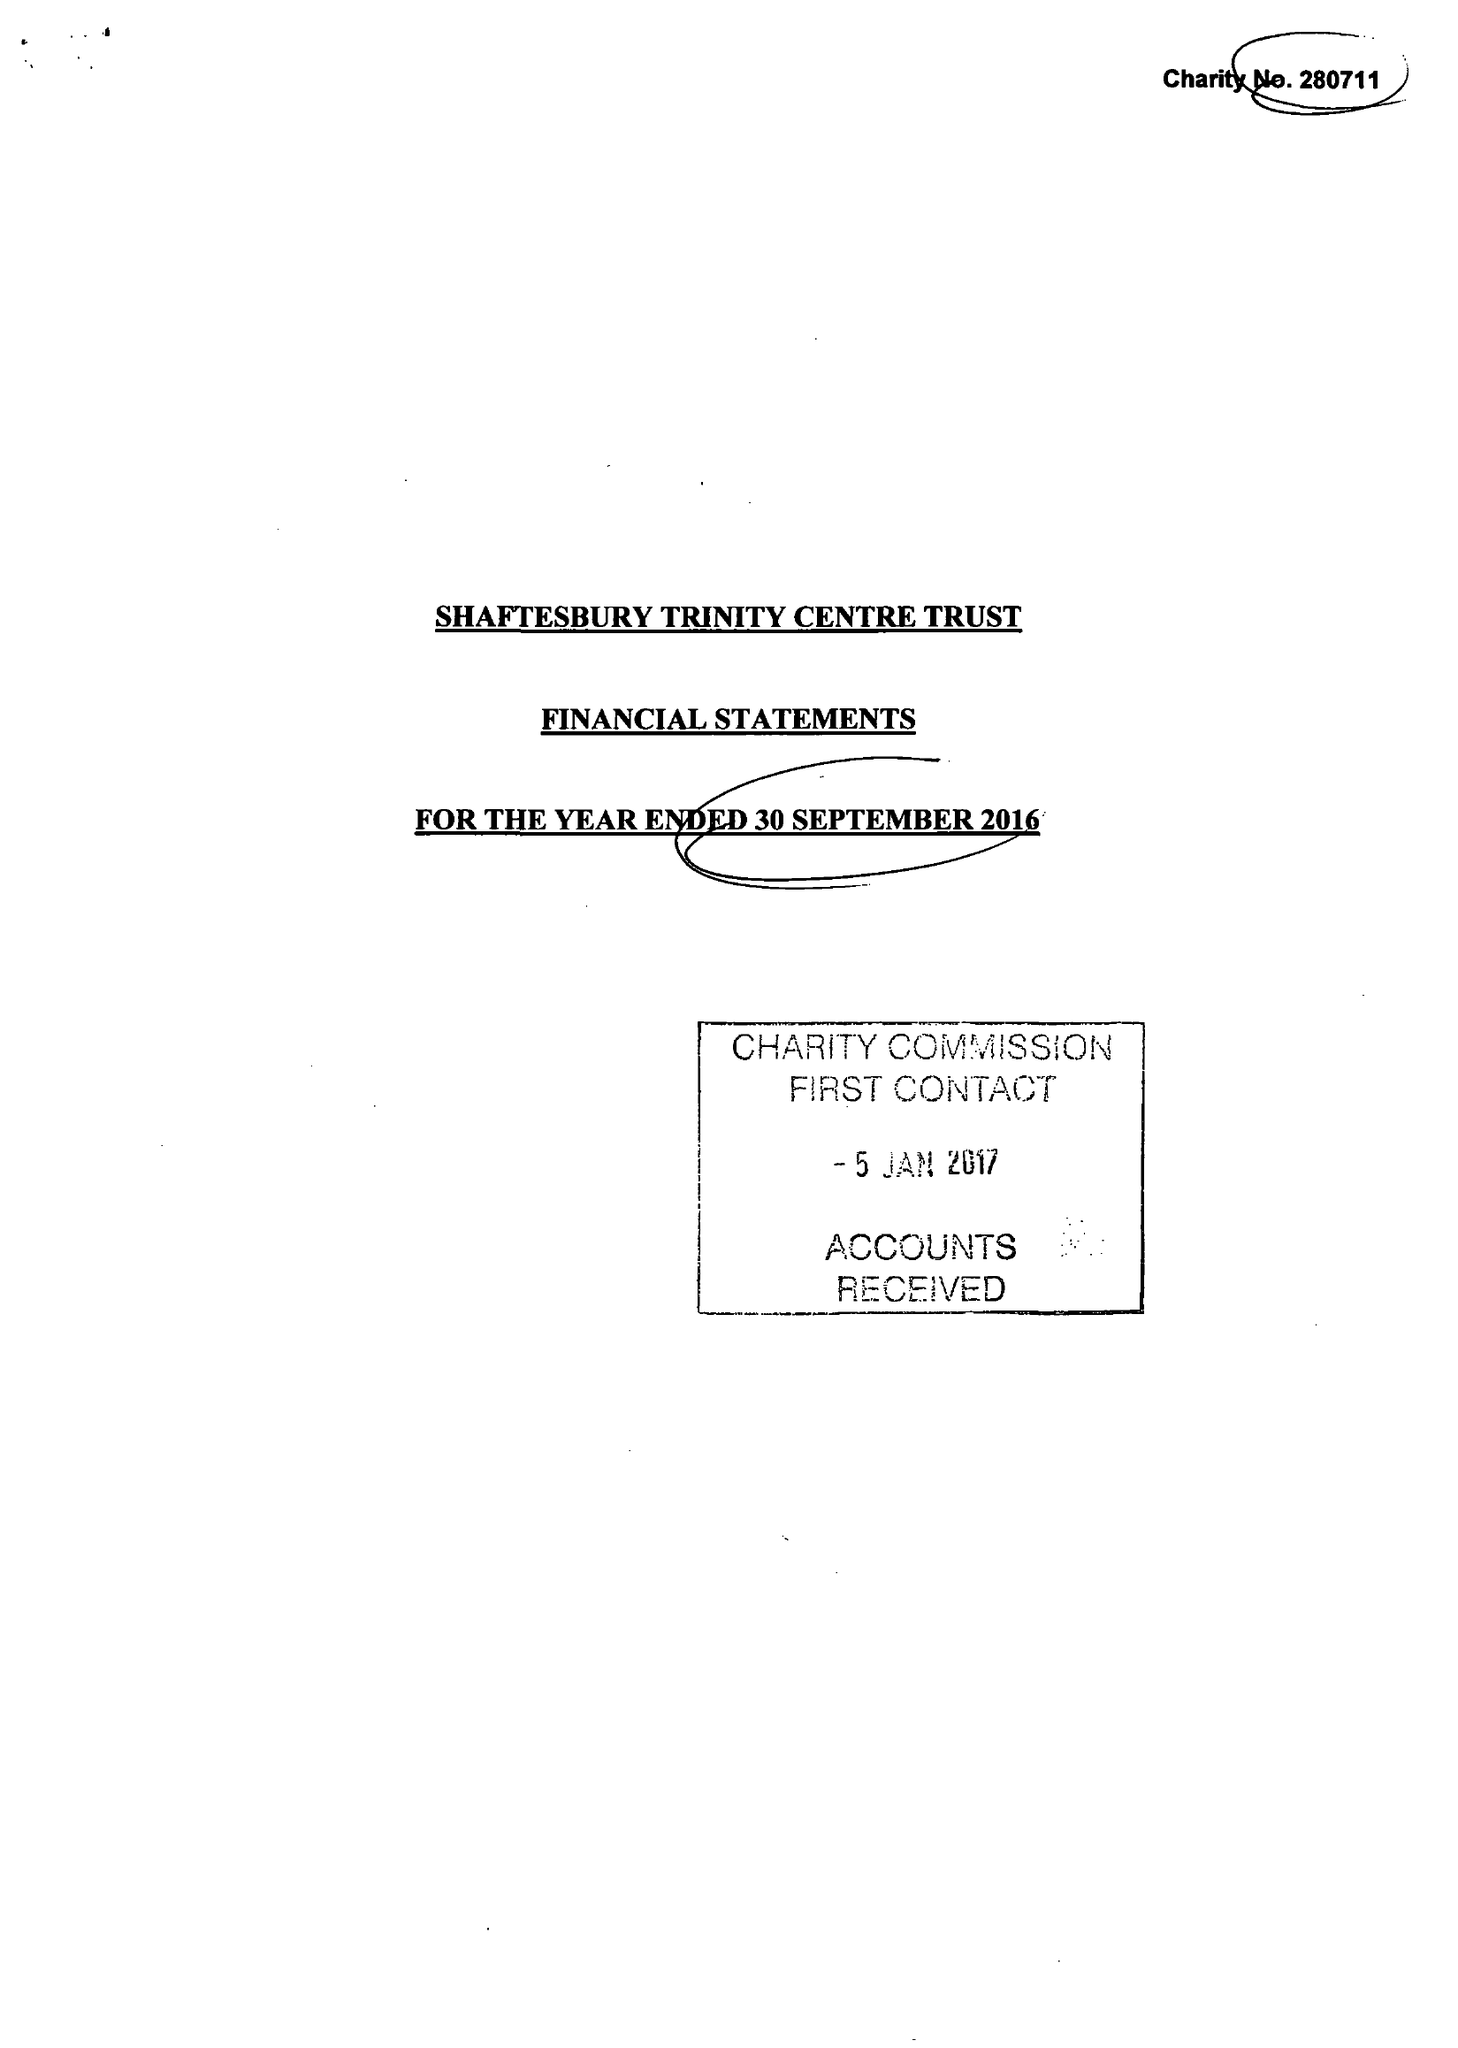What is the value for the address__post_town?
Answer the question using a single word or phrase. GILLINGHAM 